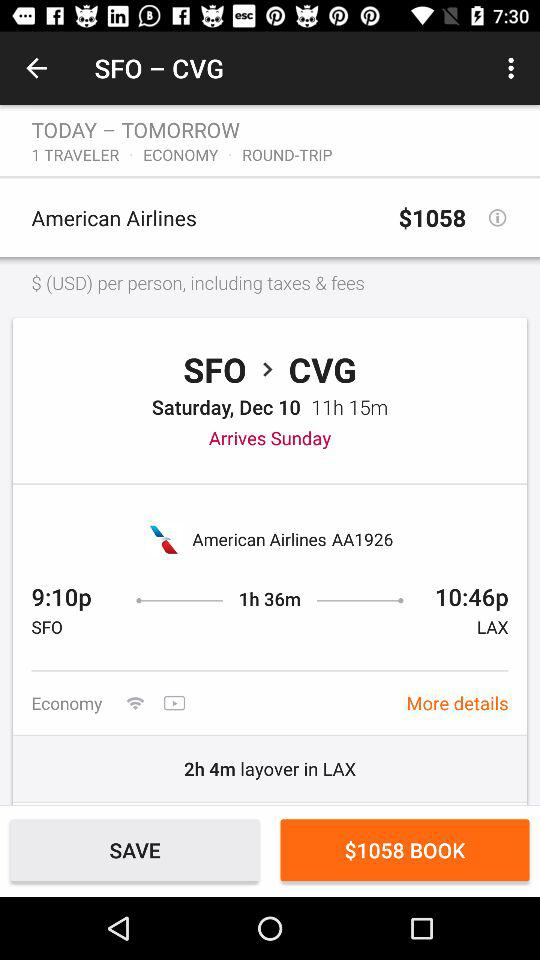Which class of flight ticket is this? The class is "ECONOMY". 